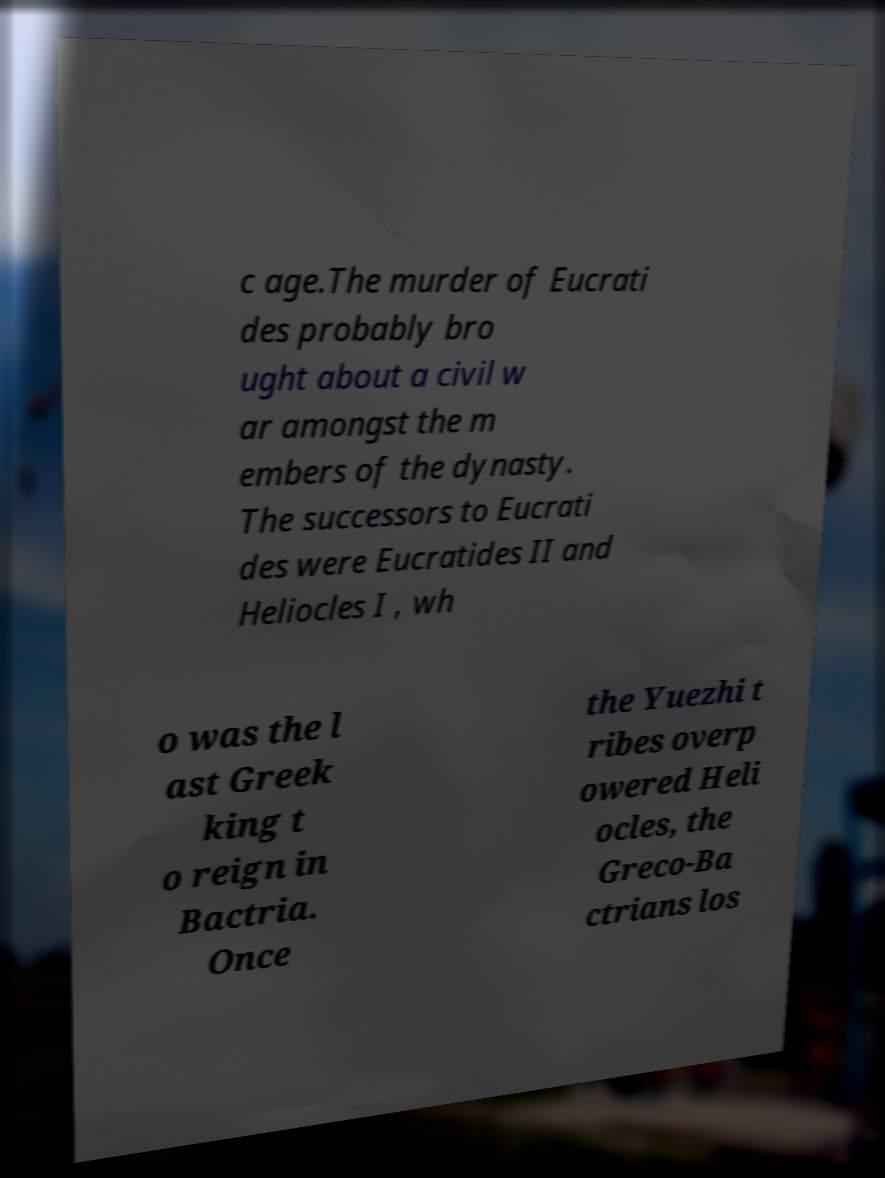What messages or text are displayed in this image? I need them in a readable, typed format. c age.The murder of Eucrati des probably bro ught about a civil w ar amongst the m embers of the dynasty. The successors to Eucrati des were Eucratides II and Heliocles I , wh o was the l ast Greek king t o reign in Bactria. Once the Yuezhi t ribes overp owered Heli ocles, the Greco-Ba ctrians los 